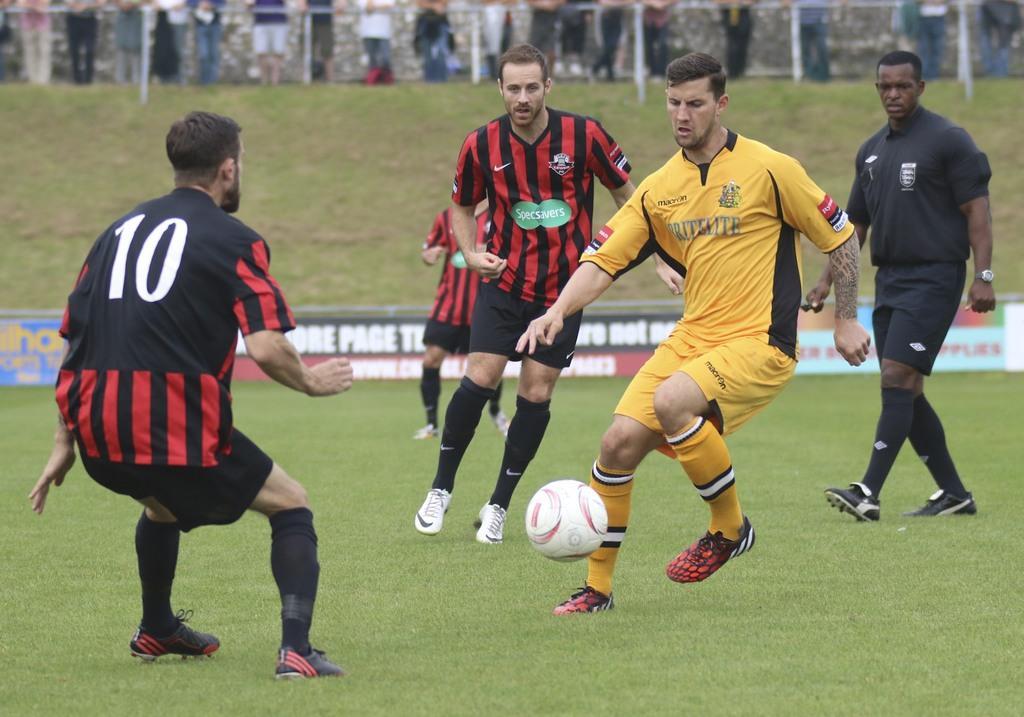How would you summarize this image in a sentence or two? In this image we can see people are playing on the ground. Here we can see a ball, hoardings, grass, and poles. In the background we can see people and wall. 